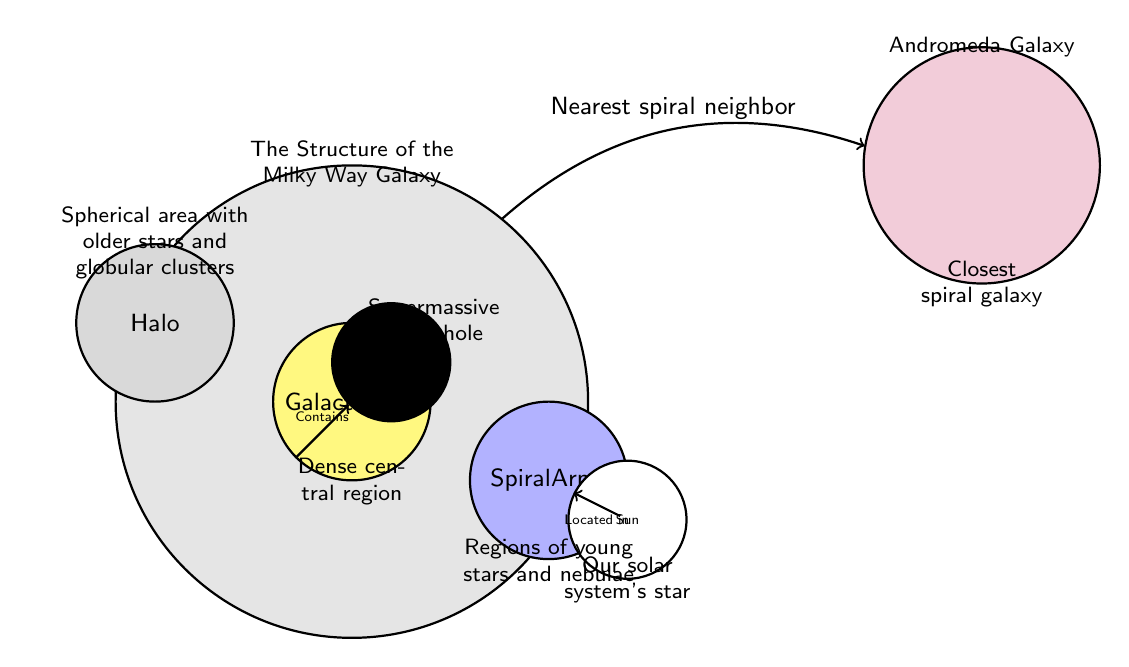What is the central component of the Milky Way Galaxy? The central component is labeled as "Galactic Core" in the diagram.
Answer: Galactic Core Which astronomical object is located in the Galactic Core? According to the diagram, "Sagittarius A*" is placed within the Galactic Core, connected with an arrow indicating that it is contained therein.
Answer: Sagittarius A* What color represents the Spiral Arms? The Spiral Arms are color-coded in blue with a specific fill color in the diagram.
Answer: Blue How many main components are illustrated in the Milky Way Galaxy? The diagram shows three main components: Galactic Core, Spiral Arms, and Halo.
Answer: Three What do the Spiral Arms contain? The diagram states that the Spiral Arms are regions of young stars and nebulae, illustrating the characteristic features of these parts of the galaxy.
Answer: Young stars and nebulae Which star is indicated as part of the Solar System? The diagram specifies "Sun" as the star associated with our Solar System, providing its location within the Spiral Arms.
Answer: Sun Which galaxy is the nearest spiral neighbor to the Milky Way? The label in the diagram indicates that "Andromeda Galaxy" is the nearest spiral neighbor.
Answer: Andromeda Galaxy What sphere surrounds the center of the Milky Way Galaxy? According to the diagram, the "Halo" surrounds the central regions, designated as a spherical area.
Answer: Halo What does the arrow from the Milky Way to Andromeda indicate? The arrow specifies that Andromeda is the nearest spiral neighbor to the Milky Way, demonstrating their proximity in the diagram.
Answer: Nearest spiral neighbor 